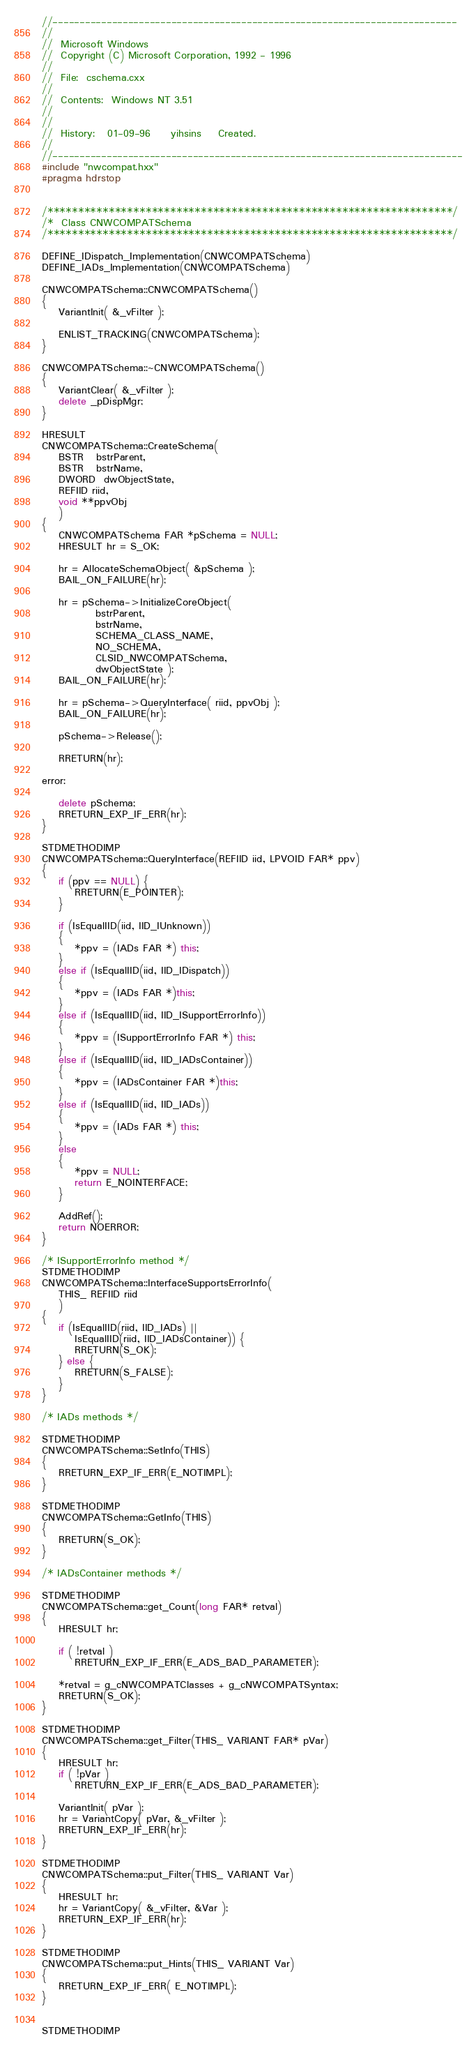<code> <loc_0><loc_0><loc_500><loc_500><_C++_>//---------------------------------------------------------------------------
//
//  Microsoft Windows
//  Copyright (C) Microsoft Corporation, 1992 - 1996
//
//  File:  cschema.cxx
//
//  Contents:  Windows NT 3.51
//
//
//  History:   01-09-96     yihsins    Created.
//
//----------------------------------------------------------------------------
#include "nwcompat.hxx"
#pragma hdrstop


/******************************************************************/
/*  Class CNWCOMPATSchema
/******************************************************************/

DEFINE_IDispatch_Implementation(CNWCOMPATSchema)
DEFINE_IADs_Implementation(CNWCOMPATSchema)

CNWCOMPATSchema::CNWCOMPATSchema()
{
    VariantInit( &_vFilter );

    ENLIST_TRACKING(CNWCOMPATSchema);
}

CNWCOMPATSchema::~CNWCOMPATSchema()
{
    VariantClear( &_vFilter );
    delete _pDispMgr;
}

HRESULT
CNWCOMPATSchema::CreateSchema(
    BSTR   bstrParent,
    BSTR   bstrName,
    DWORD  dwObjectState,
    REFIID riid,
    void **ppvObj
    )
{
    CNWCOMPATSchema FAR *pSchema = NULL;
    HRESULT hr = S_OK;

    hr = AllocateSchemaObject( &pSchema );
    BAIL_ON_FAILURE(hr);

    hr = pSchema->InitializeCoreObject(
             bstrParent,
             bstrName,
             SCHEMA_CLASS_NAME,
             NO_SCHEMA,
             CLSID_NWCOMPATSchema,
             dwObjectState );
    BAIL_ON_FAILURE(hr);

    hr = pSchema->QueryInterface( riid, ppvObj );
    BAIL_ON_FAILURE(hr);

    pSchema->Release();

    RRETURN(hr);

error:

    delete pSchema;
    RRETURN_EXP_IF_ERR(hr);
}

STDMETHODIMP
CNWCOMPATSchema::QueryInterface(REFIID iid, LPVOID FAR* ppv)
{
    if (ppv == NULL) {
        RRETURN(E_POINTER);
    }

    if (IsEqualIID(iid, IID_IUnknown))
    {
        *ppv = (IADs FAR *) this;
    }
    else if (IsEqualIID(iid, IID_IDispatch))
    {
        *ppv = (IADs FAR *)this;
    }
    else if (IsEqualIID(iid, IID_ISupportErrorInfo))
    {
        *ppv = (ISupportErrorInfo FAR *) this;
    }
    else if (IsEqualIID(iid, IID_IADsContainer))
    {
        *ppv = (IADsContainer FAR *)this;
    }
    else if (IsEqualIID(iid, IID_IADs))
    {
        *ppv = (IADs FAR *) this;
    }
    else
    {
        *ppv = NULL;
        return E_NOINTERFACE;
    }

    AddRef();
    return NOERROR;
}

/* ISupportErrorInfo method */
STDMETHODIMP
CNWCOMPATSchema::InterfaceSupportsErrorInfo(
    THIS_ REFIID riid
    )
{
    if (IsEqualIID(riid, IID_IADs) ||
        IsEqualIID(riid, IID_IADsContainer)) {
        RRETURN(S_OK);
    } else {
        RRETURN(S_FALSE);
    }
}

/* IADs methods */

STDMETHODIMP
CNWCOMPATSchema::SetInfo(THIS)
{
    RRETURN_EXP_IF_ERR(E_NOTIMPL);
}

STDMETHODIMP
CNWCOMPATSchema::GetInfo(THIS)
{
    RRETURN(S_OK);
}

/* IADsContainer methods */

STDMETHODIMP
CNWCOMPATSchema::get_Count(long FAR* retval)
{
    HRESULT hr;

    if ( !retval )
        RRETURN_EXP_IF_ERR(E_ADS_BAD_PARAMETER);

    *retval = g_cNWCOMPATClasses + g_cNWCOMPATSyntax;
    RRETURN(S_OK);
}

STDMETHODIMP
CNWCOMPATSchema::get_Filter(THIS_ VARIANT FAR* pVar)
{
    HRESULT hr;
    if ( !pVar )
        RRETURN_EXP_IF_ERR(E_ADS_BAD_PARAMETER);

    VariantInit( pVar );
    hr = VariantCopy( pVar, &_vFilter );
    RRETURN_EXP_IF_ERR(hr);
}

STDMETHODIMP
CNWCOMPATSchema::put_Filter(THIS_ VARIANT Var)
{
    HRESULT hr;
    hr = VariantCopy( &_vFilter, &Var );
    RRETURN_EXP_IF_ERR(hr);
}

STDMETHODIMP
CNWCOMPATSchema::put_Hints(THIS_ VARIANT Var)
{
    RRETURN_EXP_IF_ERR( E_NOTIMPL);
}


STDMETHODIMP</code> 